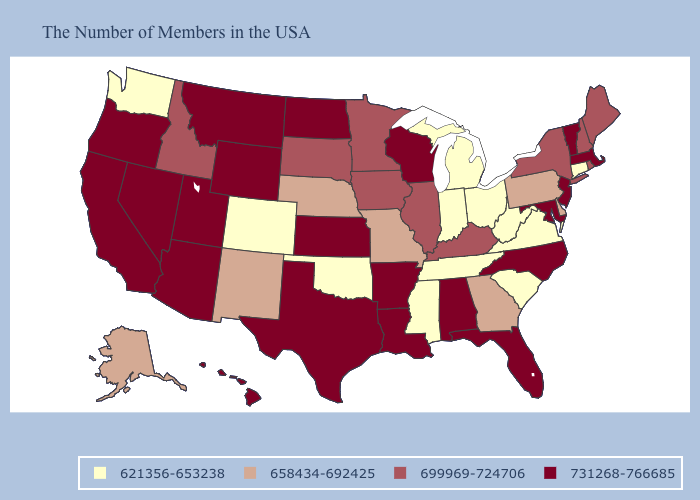Among the states that border Utah , does Colorado have the lowest value?
Quick response, please. Yes. What is the lowest value in states that border New York?
Be succinct. 621356-653238. What is the lowest value in the West?
Short answer required. 621356-653238. What is the highest value in states that border New Mexico?
Be succinct. 731268-766685. What is the highest value in the USA?
Concise answer only. 731268-766685. Does Indiana have the highest value in the MidWest?
Give a very brief answer. No. Name the states that have a value in the range 658434-692425?
Be succinct. Delaware, Pennsylvania, Georgia, Missouri, Nebraska, New Mexico, Alaska. Does the map have missing data?
Be succinct. No. What is the value of Florida?
Write a very short answer. 731268-766685. Does Arkansas have the same value as Alaska?
Write a very short answer. No. How many symbols are there in the legend?
Write a very short answer. 4. Name the states that have a value in the range 621356-653238?
Keep it brief. Connecticut, Virginia, South Carolina, West Virginia, Ohio, Michigan, Indiana, Tennessee, Mississippi, Oklahoma, Colorado, Washington. Does Rhode Island have the lowest value in the Northeast?
Give a very brief answer. No. Name the states that have a value in the range 658434-692425?
Concise answer only. Delaware, Pennsylvania, Georgia, Missouri, Nebraska, New Mexico, Alaska. Which states have the lowest value in the USA?
Concise answer only. Connecticut, Virginia, South Carolina, West Virginia, Ohio, Michigan, Indiana, Tennessee, Mississippi, Oklahoma, Colorado, Washington. 